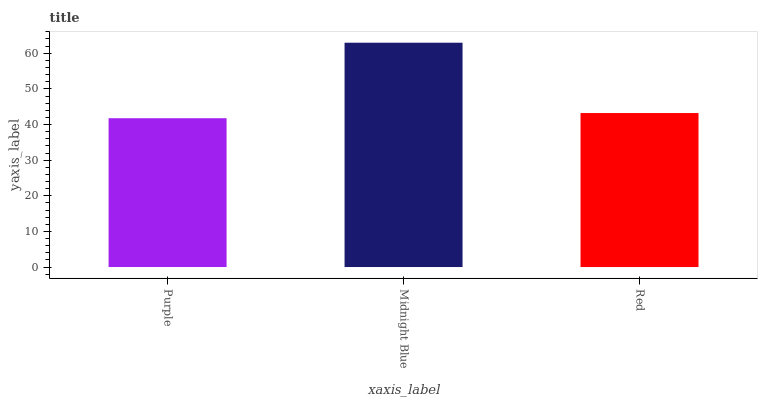Is Purple the minimum?
Answer yes or no. Yes. Is Midnight Blue the maximum?
Answer yes or no. Yes. Is Red the minimum?
Answer yes or no. No. Is Red the maximum?
Answer yes or no. No. Is Midnight Blue greater than Red?
Answer yes or no. Yes. Is Red less than Midnight Blue?
Answer yes or no. Yes. Is Red greater than Midnight Blue?
Answer yes or no. No. Is Midnight Blue less than Red?
Answer yes or no. No. Is Red the high median?
Answer yes or no. Yes. Is Red the low median?
Answer yes or no. Yes. Is Midnight Blue the high median?
Answer yes or no. No. Is Midnight Blue the low median?
Answer yes or no. No. 